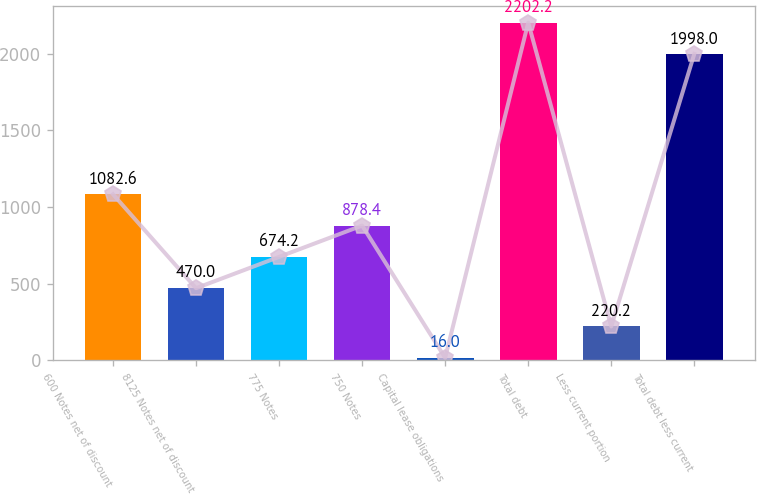<chart> <loc_0><loc_0><loc_500><loc_500><bar_chart><fcel>600 Notes net of discount<fcel>8125 Notes net of discount<fcel>775 Notes<fcel>750 Notes<fcel>Capital lease obligations<fcel>Total debt<fcel>Less current portion<fcel>Total debt less current<nl><fcel>1082.6<fcel>470<fcel>674.2<fcel>878.4<fcel>16<fcel>2202.2<fcel>220.2<fcel>1998<nl></chart> 